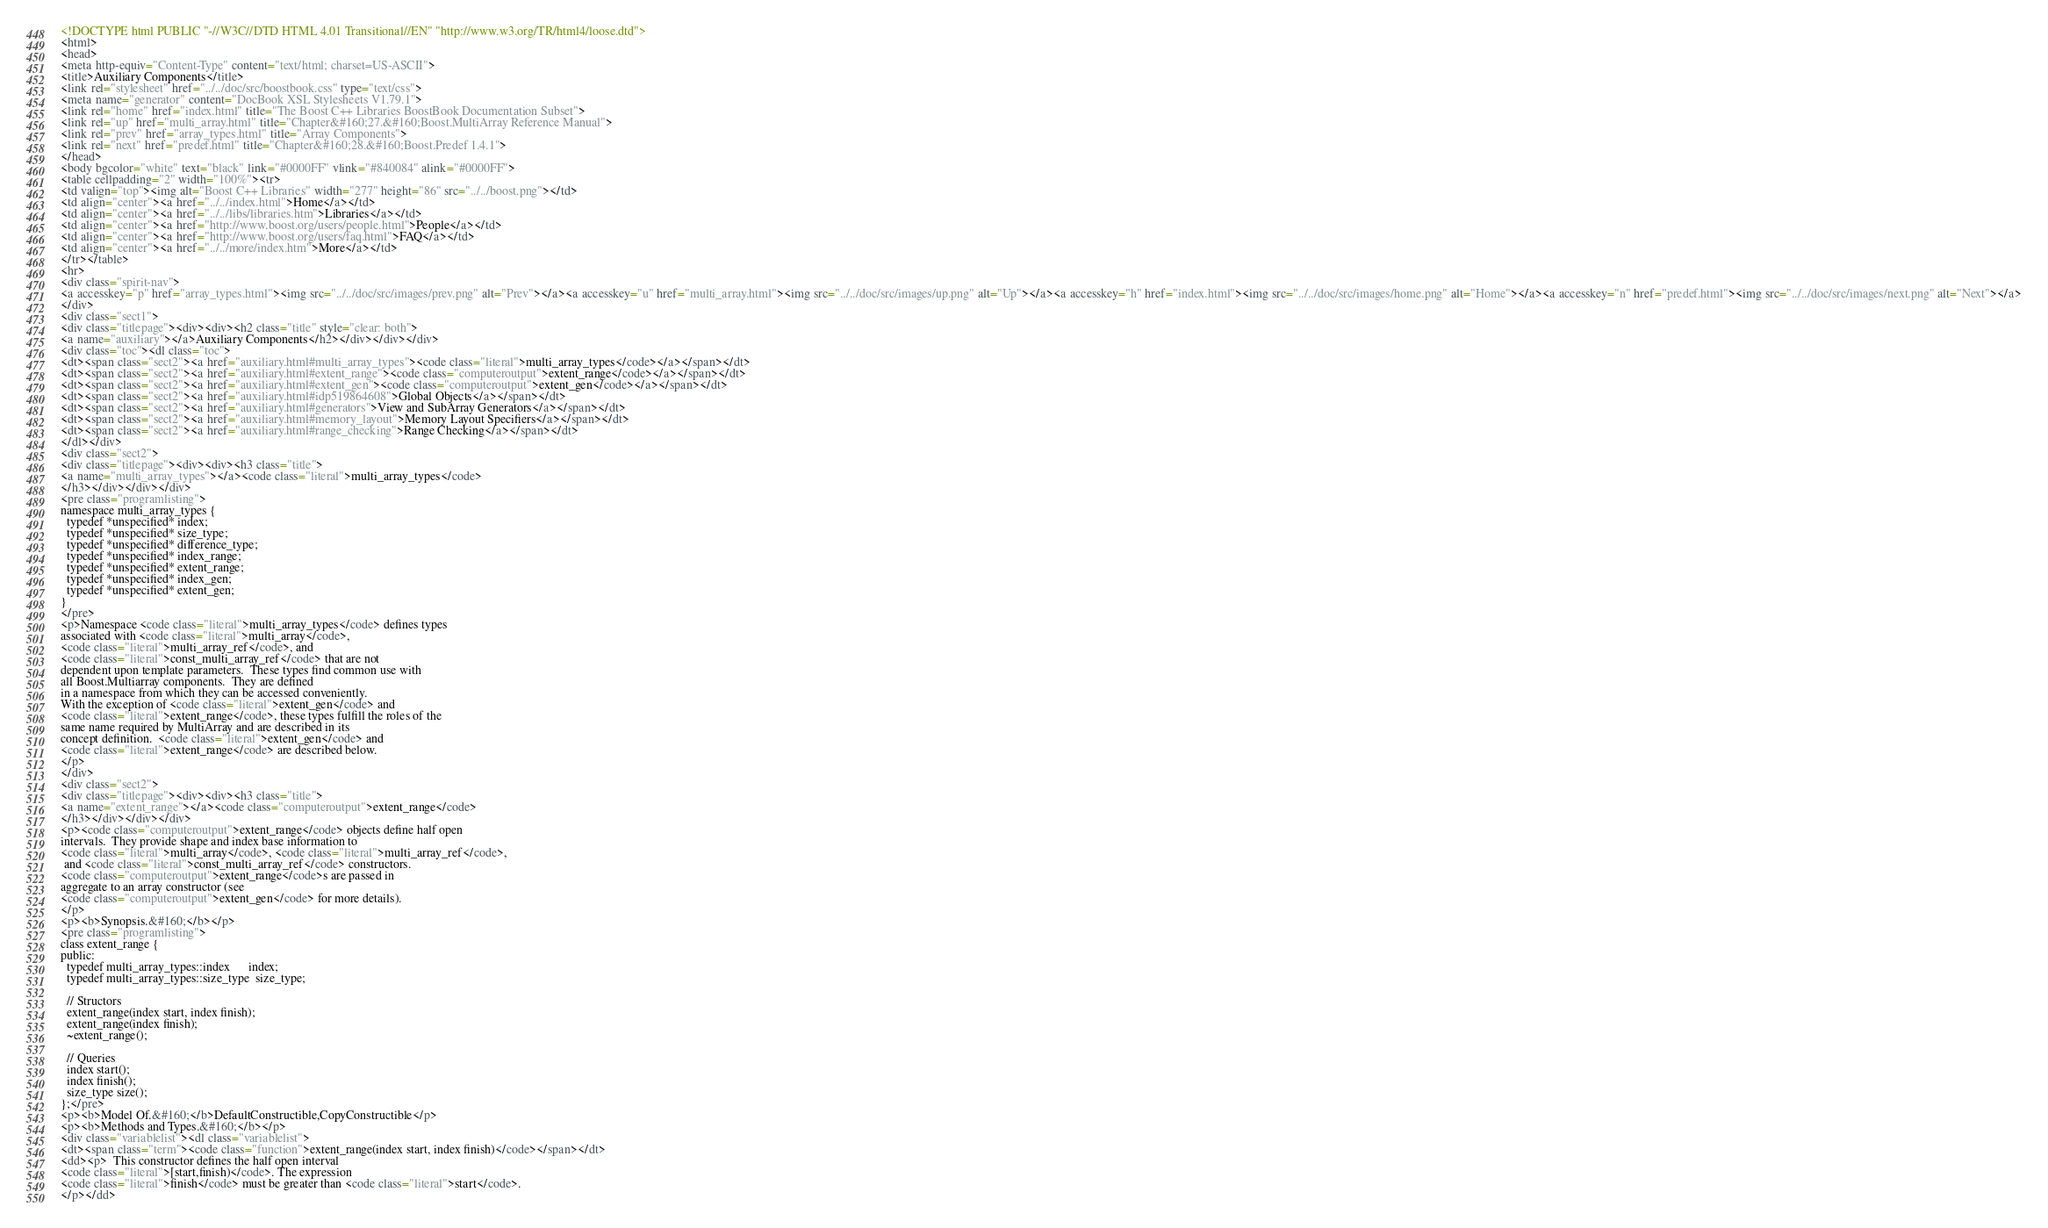Convert code to text. <code><loc_0><loc_0><loc_500><loc_500><_HTML_><!DOCTYPE html PUBLIC "-//W3C//DTD HTML 4.01 Transitional//EN" "http://www.w3.org/TR/html4/loose.dtd">
<html>
<head>
<meta http-equiv="Content-Type" content="text/html; charset=US-ASCII">
<title>Auxiliary Components</title>
<link rel="stylesheet" href="../../doc/src/boostbook.css" type="text/css">
<meta name="generator" content="DocBook XSL Stylesheets V1.79.1">
<link rel="home" href="index.html" title="The Boost C++ Libraries BoostBook Documentation Subset">
<link rel="up" href="multi_array.html" title="Chapter&#160;27.&#160;Boost.MultiArray Reference Manual">
<link rel="prev" href="array_types.html" title="Array Components">
<link rel="next" href="predef.html" title="Chapter&#160;28.&#160;Boost.Predef 1.4.1">
</head>
<body bgcolor="white" text="black" link="#0000FF" vlink="#840084" alink="#0000FF">
<table cellpadding="2" width="100%"><tr>
<td valign="top"><img alt="Boost C++ Libraries" width="277" height="86" src="../../boost.png"></td>
<td align="center"><a href="../../index.html">Home</a></td>
<td align="center"><a href="../../libs/libraries.htm">Libraries</a></td>
<td align="center"><a href="http://www.boost.org/users/people.html">People</a></td>
<td align="center"><a href="http://www.boost.org/users/faq.html">FAQ</a></td>
<td align="center"><a href="../../more/index.htm">More</a></td>
</tr></table>
<hr>
<div class="spirit-nav">
<a accesskey="p" href="array_types.html"><img src="../../doc/src/images/prev.png" alt="Prev"></a><a accesskey="u" href="multi_array.html"><img src="../../doc/src/images/up.png" alt="Up"></a><a accesskey="h" href="index.html"><img src="../../doc/src/images/home.png" alt="Home"></a><a accesskey="n" href="predef.html"><img src="../../doc/src/images/next.png" alt="Next"></a>
</div>
<div class="sect1">
<div class="titlepage"><div><div><h2 class="title" style="clear: both">
<a name="auxiliary"></a>Auxiliary Components</h2></div></div></div>
<div class="toc"><dl class="toc">
<dt><span class="sect2"><a href="auxiliary.html#multi_array_types"><code class="literal">multi_array_types</code></a></span></dt>
<dt><span class="sect2"><a href="auxiliary.html#extent_range"><code class="computeroutput">extent_range</code></a></span></dt>
<dt><span class="sect2"><a href="auxiliary.html#extent_gen"><code class="computeroutput">extent_gen</code></a></span></dt>
<dt><span class="sect2"><a href="auxiliary.html#idp519864608">Global Objects</a></span></dt>
<dt><span class="sect2"><a href="auxiliary.html#generators">View and SubArray Generators</a></span></dt>
<dt><span class="sect2"><a href="auxiliary.html#memory_layout">Memory Layout Specifiers</a></span></dt>
<dt><span class="sect2"><a href="auxiliary.html#range_checking">Range Checking</a></span></dt>
</dl></div>
<div class="sect2">
<div class="titlepage"><div><div><h3 class="title">
<a name="multi_array_types"></a><code class="literal">multi_array_types</code>
</h3></div></div></div>
<pre class="programlisting">
namespace multi_array_types {
  typedef *unspecified* index;
  typedef *unspecified* size_type;
  typedef *unspecified* difference_type;
  typedef *unspecified* index_range;
  typedef *unspecified* extent_range;
  typedef *unspecified* index_gen;
  typedef *unspecified* extent_gen;
}
</pre>
<p>Namespace <code class="literal">multi_array_types</code> defines types
associated with <code class="literal">multi_array</code>,
<code class="literal">multi_array_ref</code>, and
<code class="literal">const_multi_array_ref</code> that are not
dependent upon template parameters.  These types find common use with
all Boost.Multiarray components.  They are defined
in a namespace from which they can be accessed conveniently.
With the exception of <code class="literal">extent_gen</code> and 
<code class="literal">extent_range</code>, these types fulfill the roles of the
same name required by MultiArray and are described in its
concept definition.  <code class="literal">extent_gen</code> and
<code class="literal">extent_range</code> are described below.
</p>
</div>
<div class="sect2">
<div class="titlepage"><div><div><h3 class="title">
<a name="extent_range"></a><code class="computeroutput">extent_range</code>
</h3></div></div></div>
<p><code class="computeroutput">extent_range</code> objects define half open
intervals.  They provide shape and index base information to
<code class="literal">multi_array</code>, <code class="literal">multi_array_ref</code>,
 and <code class="literal">const_multi_array_ref</code> constructors.
<code class="computeroutput">extent_range</code>s are passed in
aggregate to an array constructor (see
<code class="computeroutput">extent_gen</code> for more details).
</p>
<p><b>Synopsis.&#160;</b></p>
<pre class="programlisting">
class extent_range {
public:
  typedef multi_array_types::index      index;
  typedef multi_array_types::size_type  size_type;

  // Structors
  extent_range(index start, index finish);
  extent_range(index finish);
  ~extent_range();

  // Queries
  index start();
  index finish();
  size_type size();
};</pre>
<p><b>Model Of.&#160;</b>DefaultConstructible,CopyConstructible</p>
<p><b>Methods and Types.&#160;</b></p>
<div class="variablelist"><dl class="variablelist">
<dt><span class="term"><code class="function">extent_range(index start, index finish)</code></span></dt>
<dd><p>  This constructor defines the half open interval
<code class="literal">[start,finish)</code>. The expression
<code class="literal">finish</code> must be greater than <code class="literal">start</code>.
</p></dd></code> 